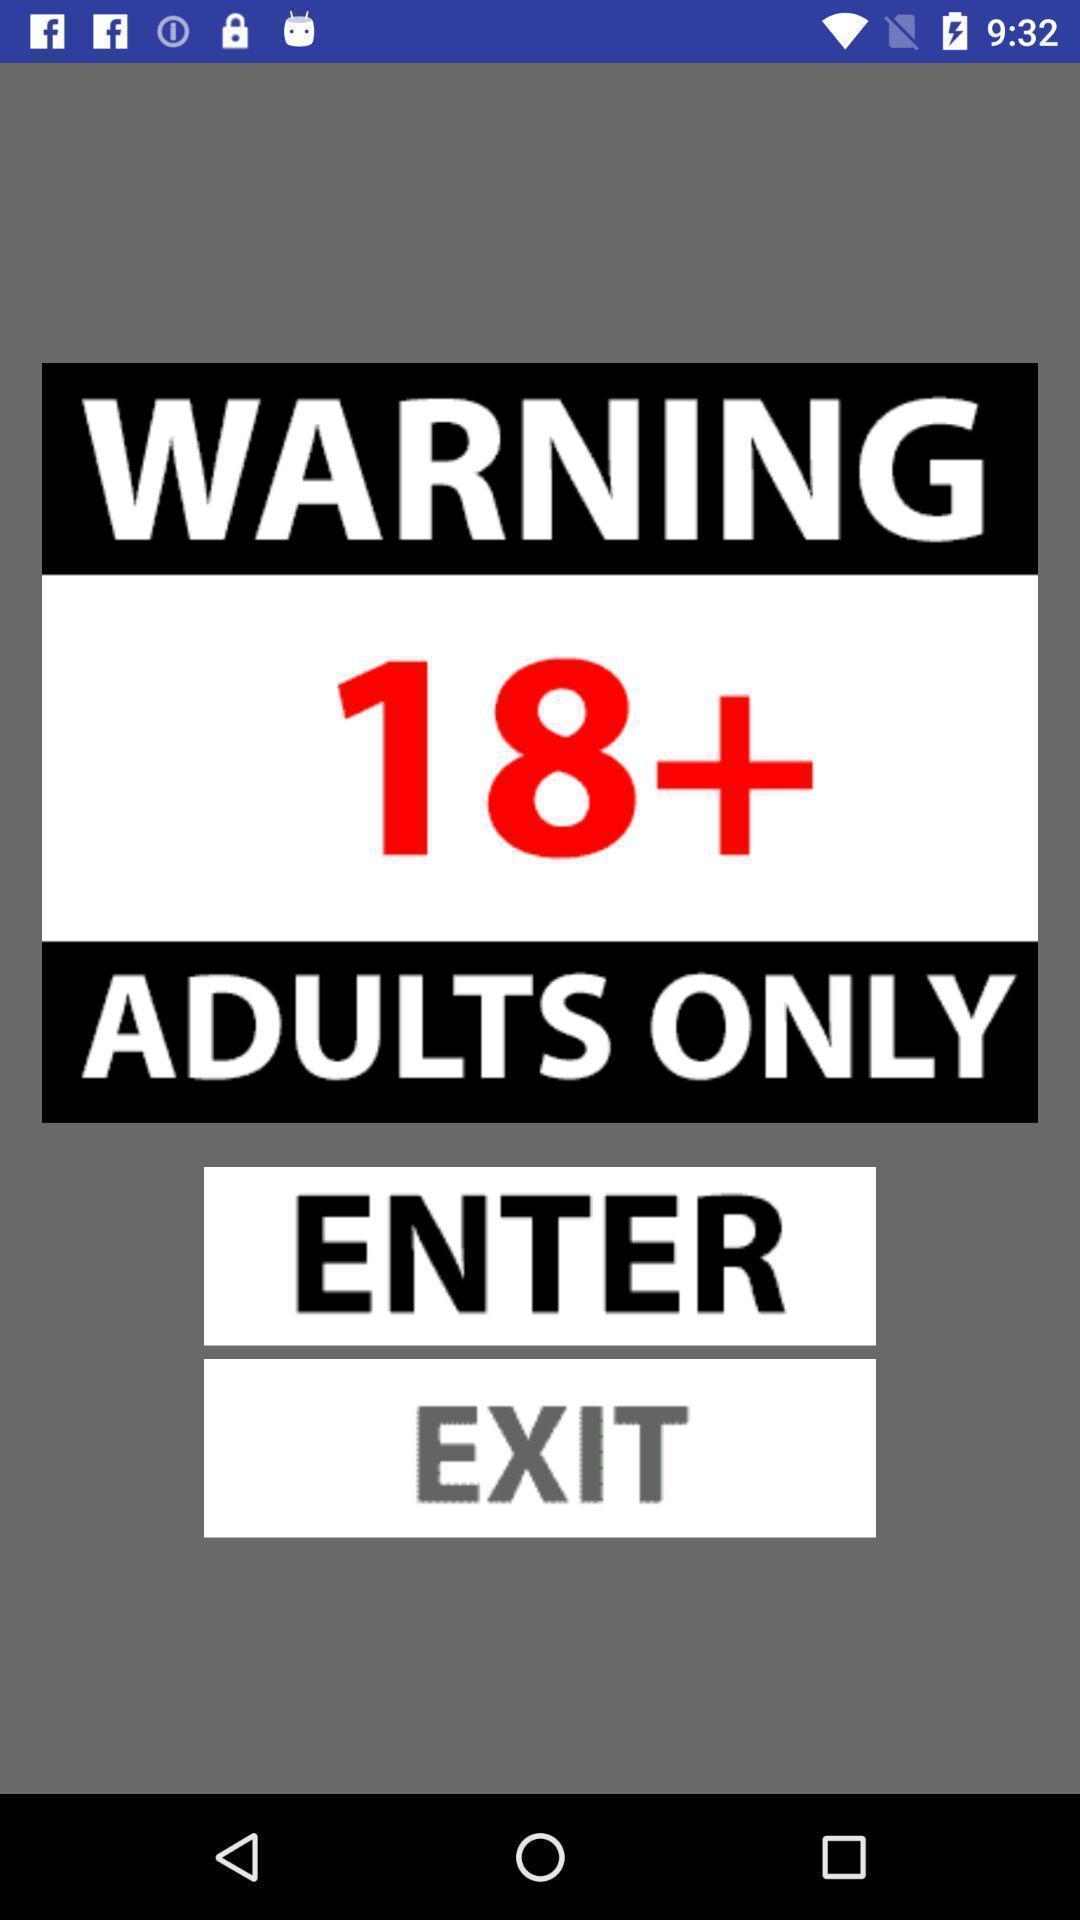Explain what's happening in this screen capture. Page displaying the warning instruction. 